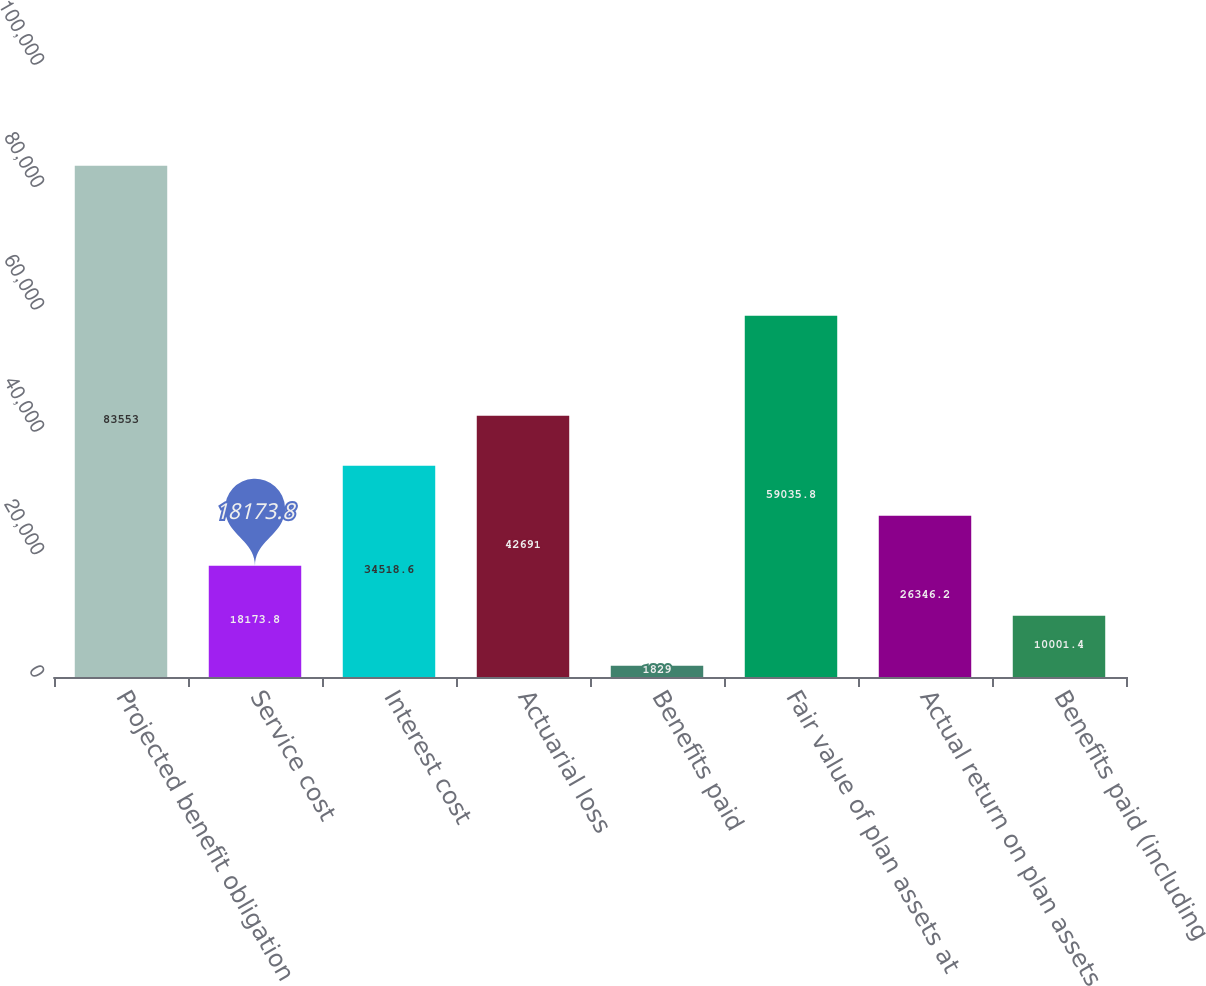Convert chart. <chart><loc_0><loc_0><loc_500><loc_500><bar_chart><fcel>Projected benefit obligation<fcel>Service cost<fcel>Interest cost<fcel>Actuarial loss<fcel>Benefits paid<fcel>Fair value of plan assets at<fcel>Actual return on plan assets<fcel>Benefits paid (including<nl><fcel>83553<fcel>18173.8<fcel>34518.6<fcel>42691<fcel>1829<fcel>59035.8<fcel>26346.2<fcel>10001.4<nl></chart> 